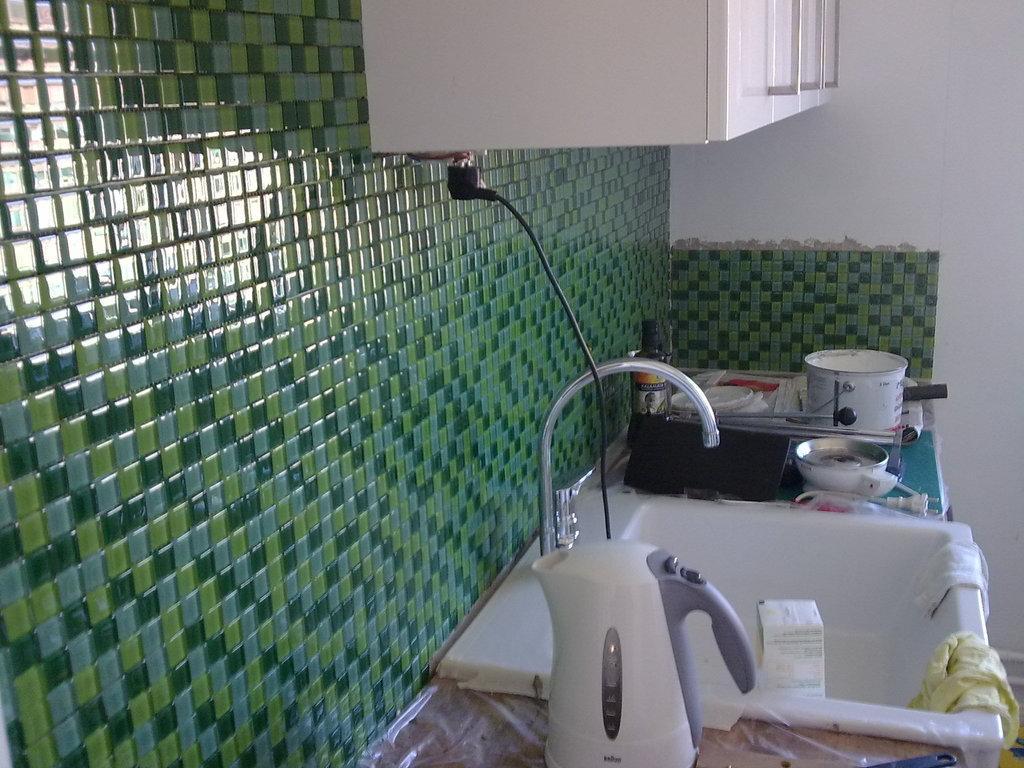Please provide a concise description of this image. This image is clicked in a kitchen. To the left, there is a wall on which there are tiles. At the bottom, there is a wash basin in white color along with the tap. To the top, there are cupboards. To the right, there is a wall. And there are bowls and vessels kept on the desk. 